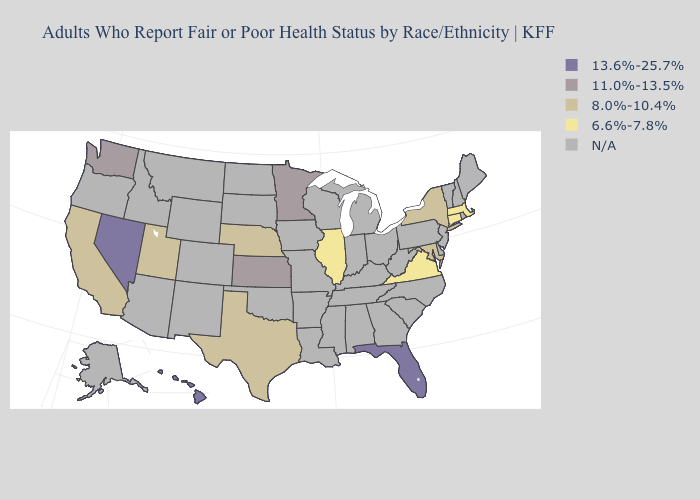Name the states that have a value in the range 6.6%-7.8%?
Be succinct. Connecticut, Illinois, Massachusetts, Virginia. Name the states that have a value in the range 8.0%-10.4%?
Answer briefly. California, Maryland, Nebraska, New York, Texas, Utah. Does New York have the lowest value in the USA?
Be succinct. No. What is the value of New Hampshire?
Be succinct. N/A. Is the legend a continuous bar?
Quick response, please. No. What is the lowest value in the West?
Short answer required. 8.0%-10.4%. What is the value of Colorado?
Short answer required. N/A. Does the first symbol in the legend represent the smallest category?
Short answer required. No. Name the states that have a value in the range 13.6%-25.7%?
Be succinct. Florida, Hawaii, Nevada. Does the first symbol in the legend represent the smallest category?
Keep it brief. No. Name the states that have a value in the range 11.0%-13.5%?
Be succinct. Kansas, Minnesota, Washington. Does Illinois have the highest value in the MidWest?
Keep it brief. No. What is the value of Virginia?
Be succinct. 6.6%-7.8%. Does New York have the lowest value in the Northeast?
Be succinct. No. 